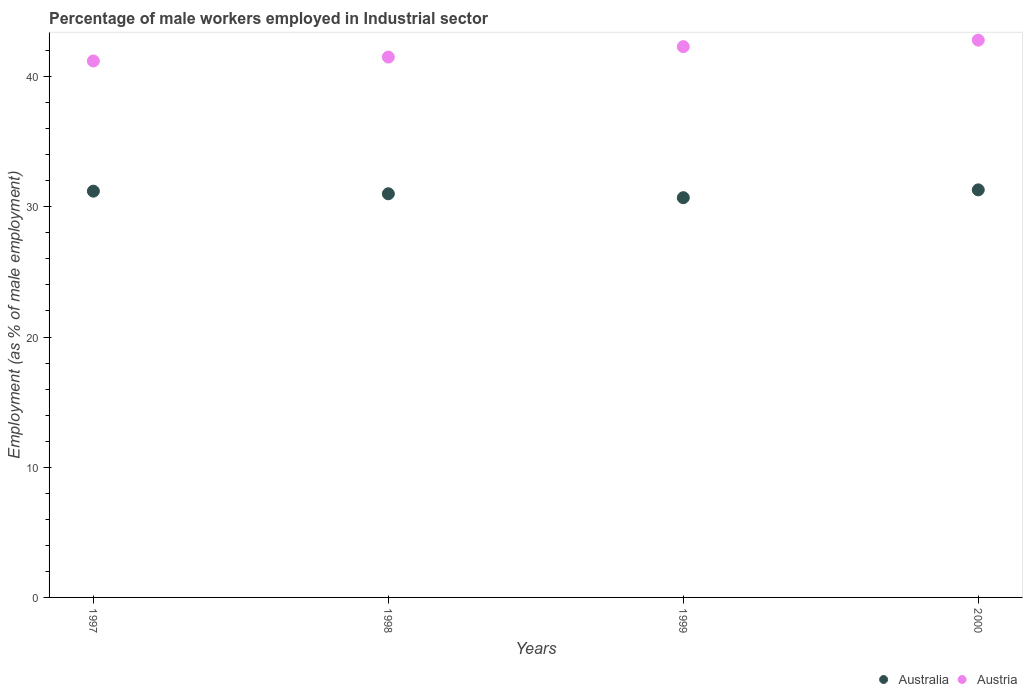How many different coloured dotlines are there?
Ensure brevity in your answer.  2. Is the number of dotlines equal to the number of legend labels?
Make the answer very short. Yes. What is the percentage of male workers employed in Industrial sector in Australia in 1997?
Keep it short and to the point. 31.2. Across all years, what is the maximum percentage of male workers employed in Industrial sector in Australia?
Your response must be concise. 31.3. Across all years, what is the minimum percentage of male workers employed in Industrial sector in Austria?
Make the answer very short. 41.2. In which year was the percentage of male workers employed in Industrial sector in Australia maximum?
Provide a succinct answer. 2000. What is the total percentage of male workers employed in Industrial sector in Australia in the graph?
Give a very brief answer. 124.2. What is the difference between the percentage of male workers employed in Industrial sector in Austria in 1998 and that in 2000?
Your answer should be compact. -1.3. What is the difference between the percentage of male workers employed in Industrial sector in Austria in 1998 and the percentage of male workers employed in Industrial sector in Australia in 2000?
Ensure brevity in your answer.  10.2. What is the average percentage of male workers employed in Industrial sector in Austria per year?
Give a very brief answer. 41.95. In the year 1999, what is the difference between the percentage of male workers employed in Industrial sector in Australia and percentage of male workers employed in Industrial sector in Austria?
Provide a short and direct response. -11.6. What is the ratio of the percentage of male workers employed in Industrial sector in Australia in 1997 to that in 2000?
Offer a very short reply. 1. Is the percentage of male workers employed in Industrial sector in Australia in 1998 less than that in 1999?
Provide a succinct answer. No. What is the difference between the highest and the second highest percentage of male workers employed in Industrial sector in Austria?
Provide a short and direct response. 0.5. What is the difference between the highest and the lowest percentage of male workers employed in Industrial sector in Australia?
Offer a terse response. 0.6. Is the sum of the percentage of male workers employed in Industrial sector in Austria in 1998 and 1999 greater than the maximum percentage of male workers employed in Industrial sector in Australia across all years?
Keep it short and to the point. Yes. Is the percentage of male workers employed in Industrial sector in Austria strictly greater than the percentage of male workers employed in Industrial sector in Australia over the years?
Make the answer very short. Yes. Is the percentage of male workers employed in Industrial sector in Australia strictly less than the percentage of male workers employed in Industrial sector in Austria over the years?
Provide a short and direct response. Yes. How many dotlines are there?
Offer a very short reply. 2. How many years are there in the graph?
Your answer should be very brief. 4. What is the difference between two consecutive major ticks on the Y-axis?
Give a very brief answer. 10. Are the values on the major ticks of Y-axis written in scientific E-notation?
Offer a terse response. No. Where does the legend appear in the graph?
Give a very brief answer. Bottom right. How are the legend labels stacked?
Offer a terse response. Horizontal. What is the title of the graph?
Your answer should be very brief. Percentage of male workers employed in Industrial sector. Does "Barbados" appear as one of the legend labels in the graph?
Offer a very short reply. No. What is the label or title of the X-axis?
Your answer should be very brief. Years. What is the label or title of the Y-axis?
Your answer should be compact. Employment (as % of male employment). What is the Employment (as % of male employment) of Australia in 1997?
Your response must be concise. 31.2. What is the Employment (as % of male employment) in Austria in 1997?
Your answer should be compact. 41.2. What is the Employment (as % of male employment) of Australia in 1998?
Keep it short and to the point. 31. What is the Employment (as % of male employment) of Austria in 1998?
Provide a succinct answer. 41.5. What is the Employment (as % of male employment) in Australia in 1999?
Give a very brief answer. 30.7. What is the Employment (as % of male employment) of Austria in 1999?
Offer a terse response. 42.3. What is the Employment (as % of male employment) in Australia in 2000?
Your response must be concise. 31.3. What is the Employment (as % of male employment) in Austria in 2000?
Offer a terse response. 42.8. Across all years, what is the maximum Employment (as % of male employment) in Australia?
Your answer should be compact. 31.3. Across all years, what is the maximum Employment (as % of male employment) of Austria?
Offer a terse response. 42.8. Across all years, what is the minimum Employment (as % of male employment) in Australia?
Ensure brevity in your answer.  30.7. Across all years, what is the minimum Employment (as % of male employment) of Austria?
Give a very brief answer. 41.2. What is the total Employment (as % of male employment) in Australia in the graph?
Your response must be concise. 124.2. What is the total Employment (as % of male employment) of Austria in the graph?
Provide a succinct answer. 167.8. What is the difference between the Employment (as % of male employment) of Australia in 1997 and that in 1998?
Provide a succinct answer. 0.2. What is the difference between the Employment (as % of male employment) in Austria in 1997 and that in 1998?
Provide a short and direct response. -0.3. What is the difference between the Employment (as % of male employment) of Australia in 1997 and that in 1999?
Ensure brevity in your answer.  0.5. What is the difference between the Employment (as % of male employment) of Australia in 1997 and that in 2000?
Offer a very short reply. -0.1. What is the difference between the Employment (as % of male employment) in Australia in 1998 and that in 1999?
Make the answer very short. 0.3. What is the difference between the Employment (as % of male employment) in Australia in 1998 and that in 2000?
Ensure brevity in your answer.  -0.3. What is the difference between the Employment (as % of male employment) in Australia in 1999 and that in 2000?
Provide a short and direct response. -0.6. What is the difference between the Employment (as % of male employment) in Australia in 1997 and the Employment (as % of male employment) in Austria in 1998?
Keep it short and to the point. -10.3. What is the difference between the Employment (as % of male employment) in Australia in 1998 and the Employment (as % of male employment) in Austria in 1999?
Offer a terse response. -11.3. What is the difference between the Employment (as % of male employment) of Australia in 1999 and the Employment (as % of male employment) of Austria in 2000?
Provide a short and direct response. -12.1. What is the average Employment (as % of male employment) in Australia per year?
Offer a terse response. 31.05. What is the average Employment (as % of male employment) of Austria per year?
Provide a short and direct response. 41.95. What is the ratio of the Employment (as % of male employment) of Australia in 1997 to that in 1998?
Provide a short and direct response. 1.01. What is the ratio of the Employment (as % of male employment) in Austria in 1997 to that in 1998?
Make the answer very short. 0.99. What is the ratio of the Employment (as % of male employment) of Australia in 1997 to that in 1999?
Your answer should be compact. 1.02. What is the ratio of the Employment (as % of male employment) in Australia in 1997 to that in 2000?
Make the answer very short. 1. What is the ratio of the Employment (as % of male employment) in Austria in 1997 to that in 2000?
Offer a very short reply. 0.96. What is the ratio of the Employment (as % of male employment) of Australia in 1998 to that in 1999?
Ensure brevity in your answer.  1.01. What is the ratio of the Employment (as % of male employment) in Austria in 1998 to that in 1999?
Provide a succinct answer. 0.98. What is the ratio of the Employment (as % of male employment) in Austria in 1998 to that in 2000?
Your answer should be very brief. 0.97. What is the ratio of the Employment (as % of male employment) of Australia in 1999 to that in 2000?
Your response must be concise. 0.98. What is the ratio of the Employment (as % of male employment) of Austria in 1999 to that in 2000?
Provide a succinct answer. 0.99. What is the difference between the highest and the second highest Employment (as % of male employment) in Australia?
Make the answer very short. 0.1. What is the difference between the highest and the lowest Employment (as % of male employment) in Australia?
Your answer should be very brief. 0.6. 